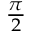<formula> <loc_0><loc_0><loc_500><loc_500>\begin{array} { l } { { \frac { \pi } { 2 } } } \end{array}</formula> 